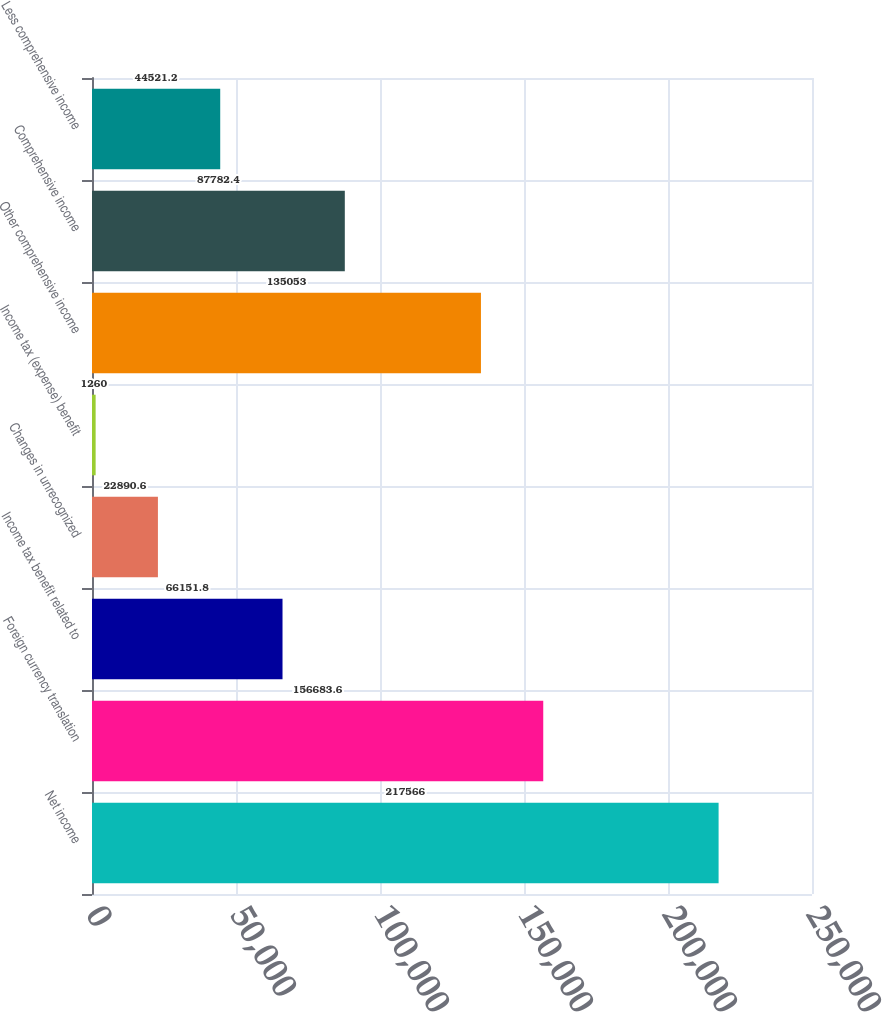<chart> <loc_0><loc_0><loc_500><loc_500><bar_chart><fcel>Net income<fcel>Foreign currency translation<fcel>Income tax benefit related to<fcel>Changes in unrecognized<fcel>Income tax (expense) benefit<fcel>Other comprehensive income<fcel>Comprehensive income<fcel>Less comprehensive income<nl><fcel>217566<fcel>156684<fcel>66151.8<fcel>22890.6<fcel>1260<fcel>135053<fcel>87782.4<fcel>44521.2<nl></chart> 